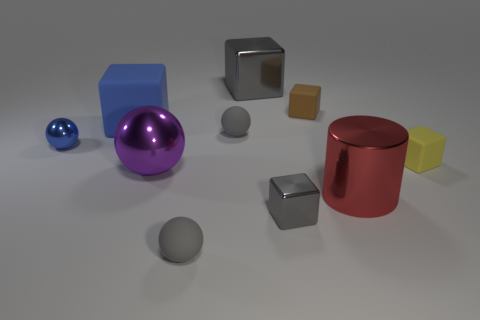Subtract all big blue rubber blocks. How many blocks are left? 4 Subtract all blue blocks. How many blocks are left? 4 Subtract all cylinders. How many objects are left? 9 Subtract all cyan cylinders. How many purple blocks are left? 0 Subtract all metal spheres. Subtract all big brown rubber cylinders. How many objects are left? 8 Add 1 blue cubes. How many blue cubes are left? 2 Add 3 big cubes. How many big cubes exist? 5 Subtract 0 yellow balls. How many objects are left? 10 Subtract 2 cubes. How many cubes are left? 3 Subtract all cyan balls. Subtract all red cubes. How many balls are left? 4 